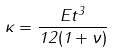Convert formula to latex. <formula><loc_0><loc_0><loc_500><loc_500>\kappa = \frac { E t ^ { 3 } } { 1 2 ( 1 + \nu ) }</formula> 